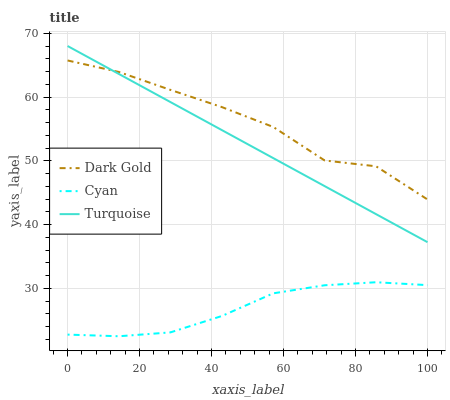Does Cyan have the minimum area under the curve?
Answer yes or no. Yes. Does Dark Gold have the maximum area under the curve?
Answer yes or no. Yes. Does Turquoise have the minimum area under the curve?
Answer yes or no. No. Does Turquoise have the maximum area under the curve?
Answer yes or no. No. Is Turquoise the smoothest?
Answer yes or no. Yes. Is Dark Gold the roughest?
Answer yes or no. Yes. Is Dark Gold the smoothest?
Answer yes or no. No. Is Turquoise the roughest?
Answer yes or no. No. Does Cyan have the lowest value?
Answer yes or no. Yes. Does Turquoise have the lowest value?
Answer yes or no. No. Does Turquoise have the highest value?
Answer yes or no. Yes. Does Dark Gold have the highest value?
Answer yes or no. No. Is Cyan less than Dark Gold?
Answer yes or no. Yes. Is Dark Gold greater than Cyan?
Answer yes or no. Yes. Does Dark Gold intersect Turquoise?
Answer yes or no. Yes. Is Dark Gold less than Turquoise?
Answer yes or no. No. Is Dark Gold greater than Turquoise?
Answer yes or no. No. Does Cyan intersect Dark Gold?
Answer yes or no. No. 